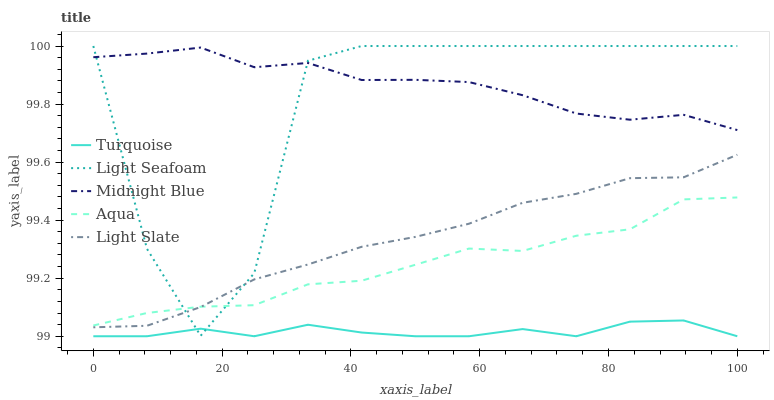Does Turquoise have the minimum area under the curve?
Answer yes or no. Yes. Does Midnight Blue have the maximum area under the curve?
Answer yes or no. Yes. Does Light Seafoam have the minimum area under the curve?
Answer yes or no. No. Does Light Seafoam have the maximum area under the curve?
Answer yes or no. No. Is Light Slate the smoothest?
Answer yes or no. Yes. Is Light Seafoam the roughest?
Answer yes or no. Yes. Is Turquoise the smoothest?
Answer yes or no. No. Is Turquoise the roughest?
Answer yes or no. No. Does Light Seafoam have the lowest value?
Answer yes or no. No. Does Light Seafoam have the highest value?
Answer yes or no. Yes. Does Turquoise have the highest value?
Answer yes or no. No. Is Aqua less than Midnight Blue?
Answer yes or no. Yes. Is Aqua greater than Turquoise?
Answer yes or no. Yes. Does Light Seafoam intersect Light Slate?
Answer yes or no. Yes. Is Light Seafoam less than Light Slate?
Answer yes or no. No. Is Light Seafoam greater than Light Slate?
Answer yes or no. No. Does Aqua intersect Midnight Blue?
Answer yes or no. No. 